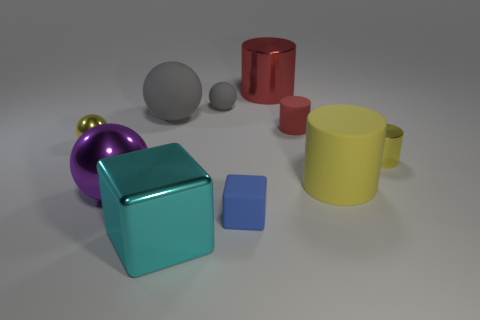Are there fewer large cylinders right of the big matte cylinder than small blue rubber objects to the left of the cyan object?
Ensure brevity in your answer.  No. There is a big thing that is both to the left of the big red object and behind the small red rubber object; what shape is it?
Your answer should be compact. Sphere. What size is the yellow thing that is the same material as the small block?
Your response must be concise. Large. Do the small metallic ball and the shiny cylinder that is in front of the red metallic thing have the same color?
Ensure brevity in your answer.  Yes. What material is the tiny object that is both in front of the small yellow shiny sphere and behind the rubber cube?
Your response must be concise. Metal. The metal cylinder that is the same color as the small matte cylinder is what size?
Your response must be concise. Large. There is a tiny yellow object that is right of the big cyan metal object; is it the same shape as the blue object that is to the left of the big yellow rubber cylinder?
Ensure brevity in your answer.  No. Is there a matte cube?
Ensure brevity in your answer.  Yes. What is the color of the other large thing that is the same shape as the blue thing?
Provide a short and direct response. Cyan. The metallic cube that is the same size as the yellow rubber object is what color?
Give a very brief answer. Cyan. 